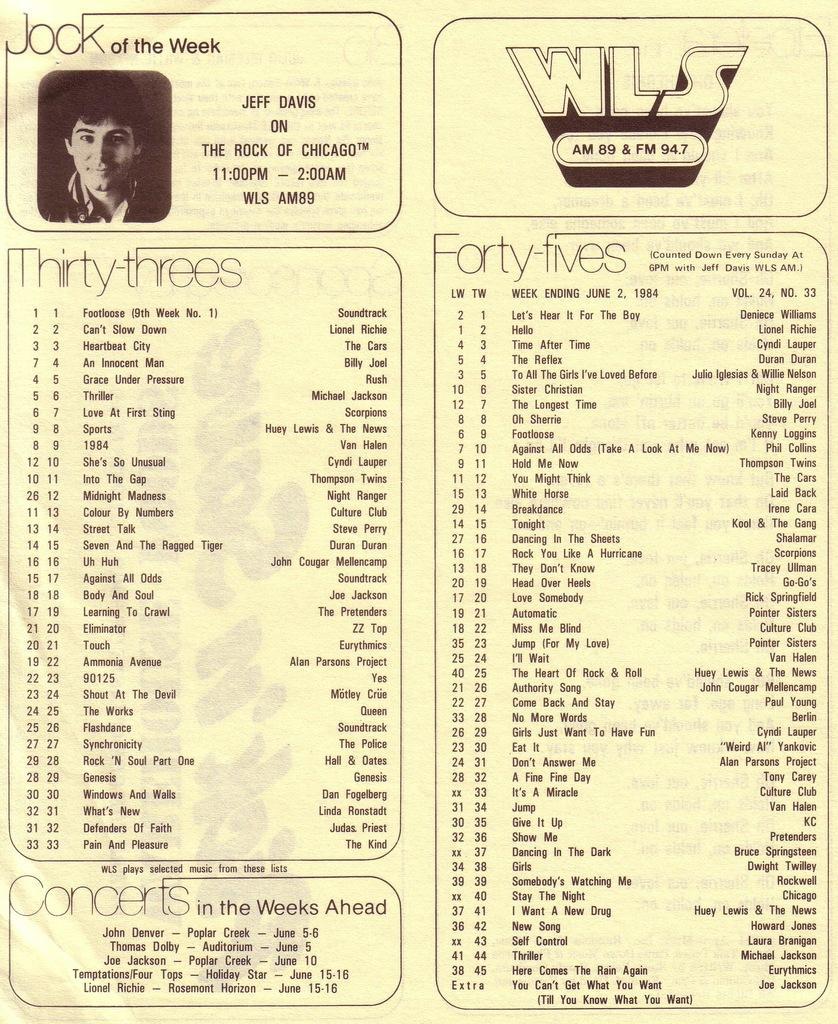How would you summarize this image in a sentence or two? In this image we can see a poster which some text and there is a picture of a person. 